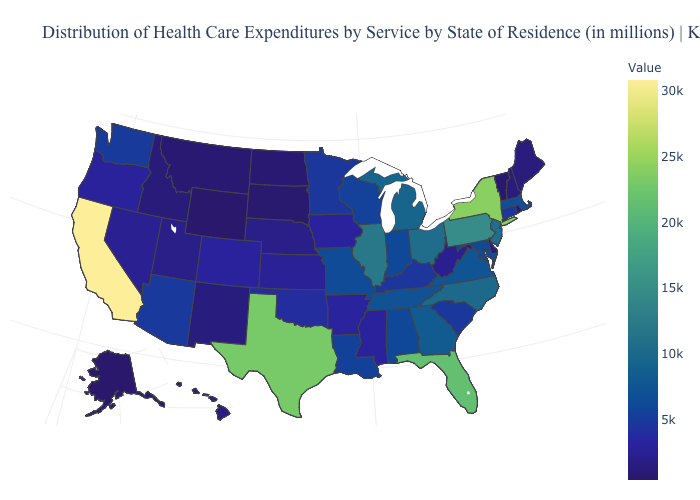Among the states that border Virginia , does Tennessee have the highest value?
Short answer required. No. Does Connecticut have a higher value than Rhode Island?
Quick response, please. Yes. Does California have the highest value in the USA?
Be succinct. Yes. Does Connecticut have the highest value in the Northeast?
Short answer required. No. Does California have the highest value in the USA?
Quick response, please. Yes. 